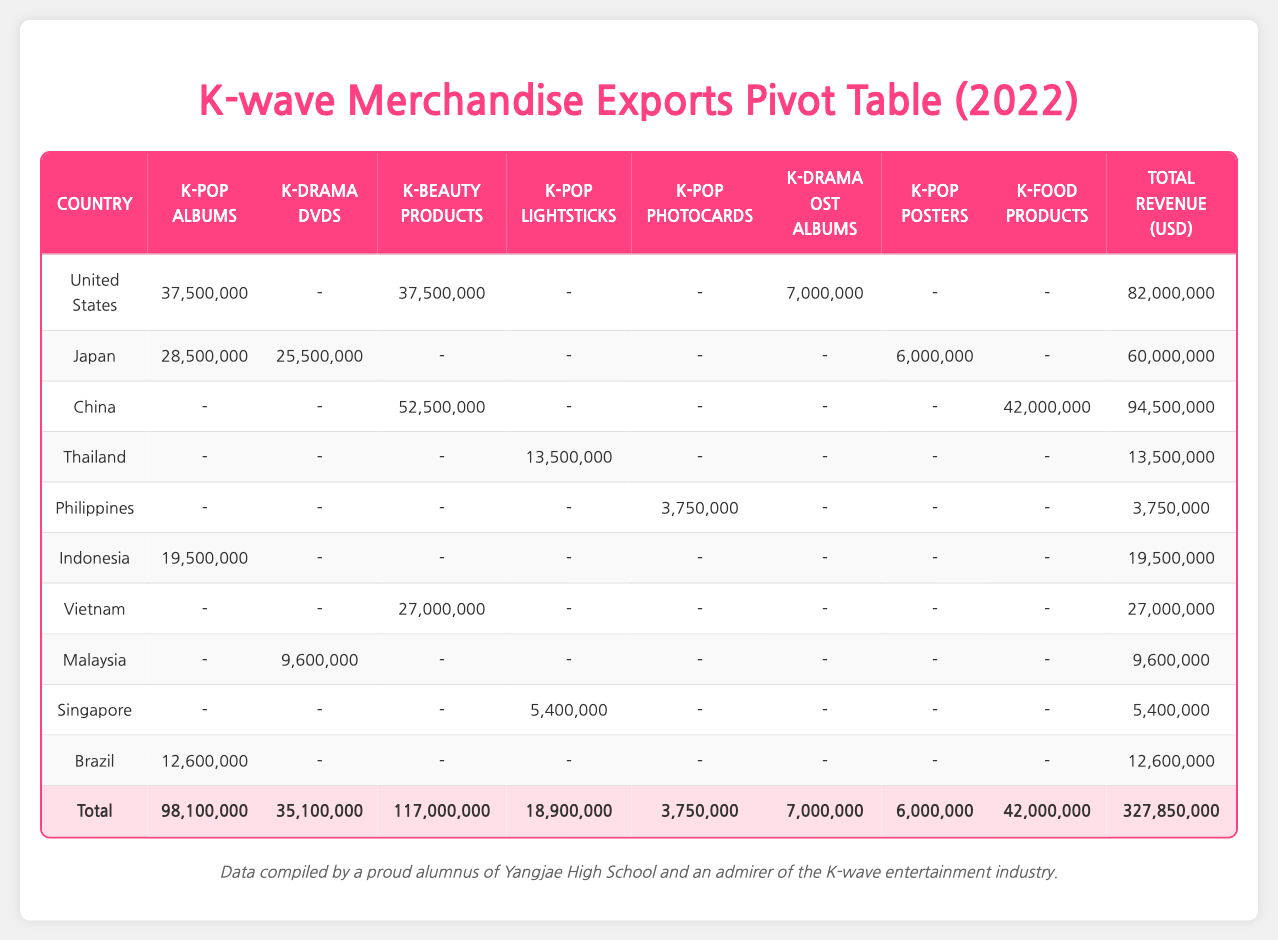What is the total revenue generated by K-pop albums from the United States? The table shows that the revenue from K-pop albums in the United States is 37,500,000. There are no additional parts to add since this is a specific value extraction.
Answer: 37,500,000 Which country generated the highest revenue from K-beauty products? From the table, China's revenue for K-beauty products is 52,500,000, while the United States generated 37,500,000. China's number is higher, making it the country with the highest revenue from K-beauty products.
Answer: China What is the total revenue from K-drama DVDs across all listed countries? To find the total revenue from K-drama DVDs, we add the revenues from each country: 25,500,000 (Japan) + 9,600,000 (Malaysia) = 35,100,000. Therefore, the total is 35,100,000.
Answer: 35,100,000 Did any country have zero revenue from K-pop Lightsticks? The data reveals several countries do not have revenue recorded for K-pop Lightsticks: United States, Japan, China, Philippines, Indonesia, Vietnam, Malaysia, and Brazil, indicating that many countries indeed reported zero revenue for this product.
Answer: Yes What is the average revenue from K-food products for the countries listed? Only China (42,000,000) generates revenue from K-food products. To find the average, we divide the total revenue by the number of data points (because only one country contributes): 42,000,000 / 1 = 42,000,000.
Answer: 42,000,000 Which country had the highest sales volume for K-pop albums overall? The data shows that the United States had sales volumes of 1,250,000 units, Japan had 950,000 units, and Indonesia had 650,000 units. Thus, the United States had the highest sales volume for K-pop albums.
Answer: United States If we exclude Thailand, what would be the total revenue for K-pop Lightsticks? The only revenue recorded for K-pop Lightsticks comes from Thailand at 13,500,000, and Singapore at 5,400,000. Instead of excluding Thailand, we calculate total revenue: 13,500,000 + 5,400,000 = 18,900,000, which indicates that revenue drops if Thailand’s number is excluded.
Answer: 5,400,000 How much revenue was generated from K-pop Photocards? The only revenue noted in the table for K-pop Photocards is from the Philippines, totaling 3,750,000. This indicates that this metric was less widespread among the listed countries.
Answer: 3,750,000 What percentage of total export revenue is attributed to K-beauty products? To find this percentage, we first calculate the total revenue for all categories (327,850,000) and the total from K-beauty products (117,000,000). The percentage is calculated as (117,000,000 / 327,850,000) * 100 = approximately 35.66%.
Answer: 35.66% 